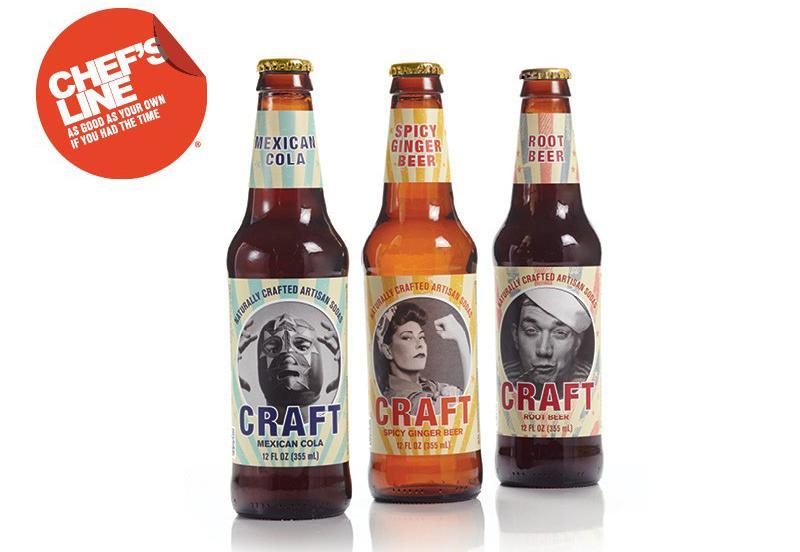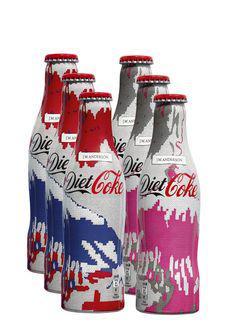The first image is the image on the left, the second image is the image on the right. Evaluate the accuracy of this statement regarding the images: "There are no more than four bottles of soda.". Is it true? Answer yes or no. No. The first image is the image on the left, the second image is the image on the right. For the images displayed, is the sentence "There is only one bottle in one of the images." factually correct? Answer yes or no. No. 